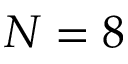<formula> <loc_0><loc_0><loc_500><loc_500>N = 8</formula> 